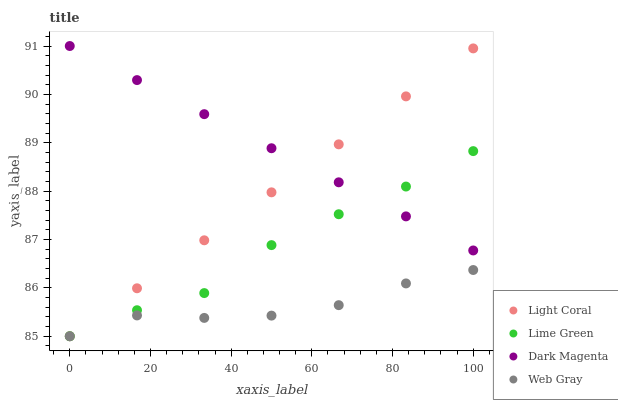Does Web Gray have the minimum area under the curve?
Answer yes or no. Yes. Does Dark Magenta have the maximum area under the curve?
Answer yes or no. Yes. Does Lime Green have the minimum area under the curve?
Answer yes or no. No. Does Lime Green have the maximum area under the curve?
Answer yes or no. No. Is Light Coral the smoothest?
Answer yes or no. Yes. Is Lime Green the roughest?
Answer yes or no. Yes. Is Web Gray the smoothest?
Answer yes or no. No. Is Web Gray the roughest?
Answer yes or no. No. Does Light Coral have the lowest value?
Answer yes or no. Yes. Does Dark Magenta have the lowest value?
Answer yes or no. No. Does Dark Magenta have the highest value?
Answer yes or no. Yes. Does Lime Green have the highest value?
Answer yes or no. No. Is Web Gray less than Dark Magenta?
Answer yes or no. Yes. Is Dark Magenta greater than Web Gray?
Answer yes or no. Yes. Does Dark Magenta intersect Light Coral?
Answer yes or no. Yes. Is Dark Magenta less than Light Coral?
Answer yes or no. No. Is Dark Magenta greater than Light Coral?
Answer yes or no. No. Does Web Gray intersect Dark Magenta?
Answer yes or no. No. 